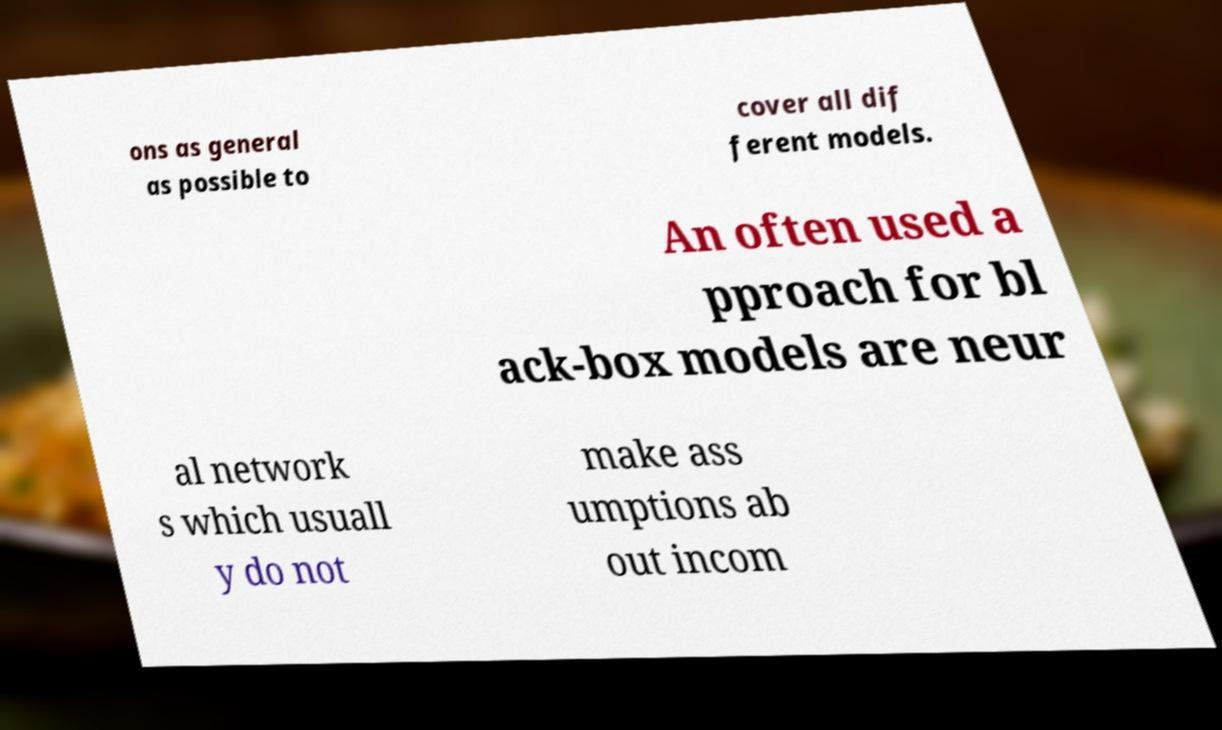For documentation purposes, I need the text within this image transcribed. Could you provide that? ons as general as possible to cover all dif ferent models. An often used a pproach for bl ack-box models are neur al network s which usuall y do not make ass umptions ab out incom 